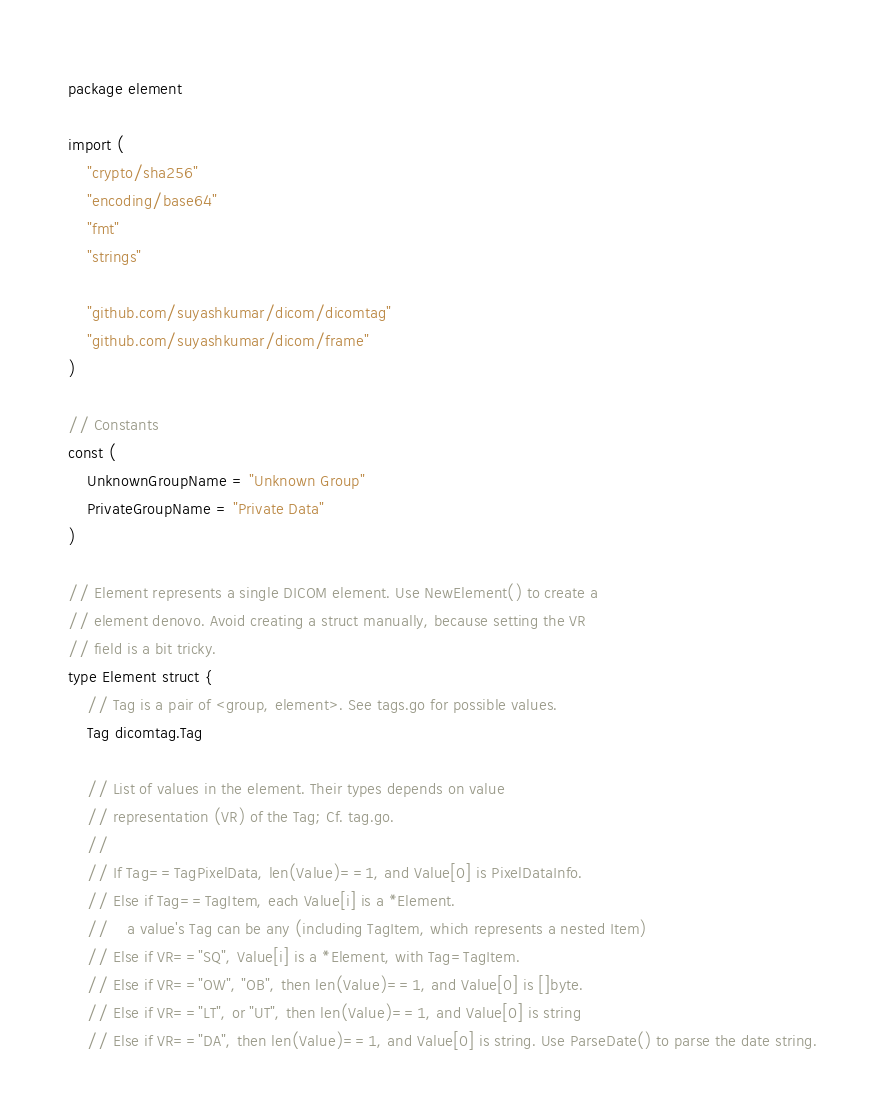Convert code to text. <code><loc_0><loc_0><loc_500><loc_500><_Go_>package element

import (
	"crypto/sha256"
	"encoding/base64"
	"fmt"
	"strings"

	"github.com/suyashkumar/dicom/dicomtag"
	"github.com/suyashkumar/dicom/frame"
)

// Constants
const (
	UnknownGroupName = "Unknown Group"
	PrivateGroupName = "Private Data"
)

// Element represents a single DICOM element. Use NewElement() to create a
// element denovo. Avoid creating a struct manually, because setting the VR
// field is a bit tricky.
type Element struct {
	// Tag is a pair of <group, element>. See tags.go for possible values.
	Tag dicomtag.Tag

	// List of values in the element. Their types depends on value
	// representation (VR) of the Tag; Cf. tag.go.
	//
	// If Tag==TagPixelData, len(Value)==1, and Value[0] is PixelDataInfo.
	// Else if Tag==TagItem, each Value[i] is a *Element.
	//    a value's Tag can be any (including TagItem, which represents a nested Item)
	// Else if VR=="SQ", Value[i] is a *Element, with Tag=TagItem.
	// Else if VR=="OW", "OB", then len(Value)==1, and Value[0] is []byte.
	// Else if VR=="LT", or "UT", then len(Value)==1, and Value[0] is string
	// Else if VR=="DA", then len(Value)==1, and Value[0] is string. Use ParseDate() to parse the date string.</code> 